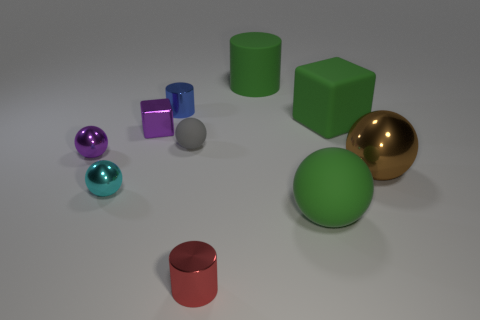Are there any large metal things in front of the small cylinder in front of the green rubber cube?
Your answer should be compact. No. The other big metal object that is the same shape as the cyan shiny object is what color?
Make the answer very short. Brown. Is there any other thing that is the same shape as the red thing?
Keep it short and to the point. Yes. There is a cube that is made of the same material as the green cylinder; what is its color?
Ensure brevity in your answer.  Green. There is a block that is to the right of the big thing behind the blue cylinder; is there a large green block on the left side of it?
Keep it short and to the point. No. Are there fewer large green rubber objects behind the cyan sphere than rubber spheres that are to the left of the large green matte ball?
Offer a terse response. No. What number of purple blocks are the same material as the red cylinder?
Your response must be concise. 1. Is the size of the purple cube the same as the green thing in front of the small purple cube?
Your response must be concise. No. There is a big block that is the same color as the big rubber cylinder; what material is it?
Your answer should be very brief. Rubber. There is a matte ball that is to the left of the rubber object that is in front of the matte ball that is left of the big cylinder; what size is it?
Your answer should be very brief. Small. 